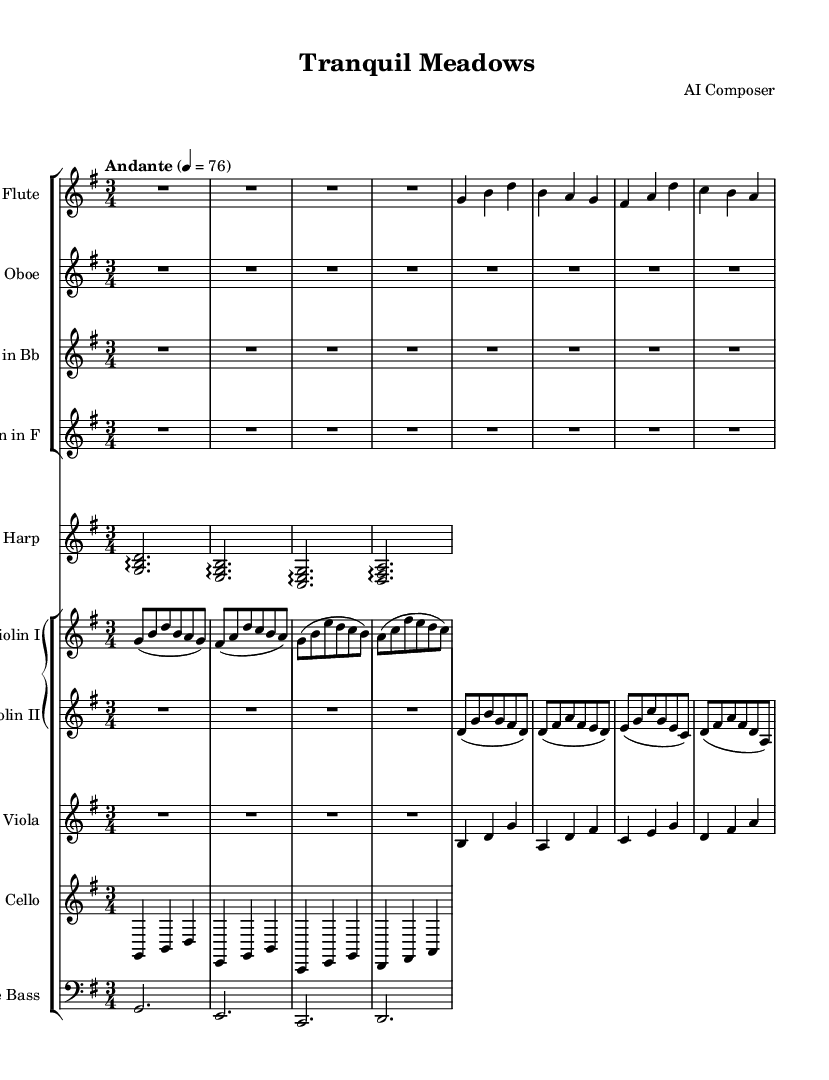What is the key signature of this music? The key signature is G major, which has one sharp (F#). This is indicated at the beginning of the staff with the sharp symbol.
Answer: G major What is the time signature of this sheet music? The time signature is 3/4, which means there are three beats in each measure, and the quarter note gets one beat. This is noticed at the beginning of the piece next to the key signature.
Answer: 3/4 What is the tempo marking for this piece? The tempo marking is "Andante," which indicates a moderate walking pace, specifically with a metronome marking of 76 beats per minute. This is shown above the staff at the beginning of the music.
Answer: Andante How many measures are present in the flute part? The flute part contains four measures, as counted from the beginning to the end of the part. Each measure is separated by a vertical line, which indicates the end of each measure.
Answer: 4 Which instruments are listed in the score? The score includes flute, oboe, clarinet in Bb, horn in F, harp, violin I, violin II, viola, cello, and double bass. Each instrument is labeled above its respective staff in the score.
Answer: Flute, oboe, clarinet in Bb, horn in F, harp, violin I, violin II, viola, cello, double bass What is the rhythmic pattern in the violin I part? The rhythmic pattern in the violin I part primarily consists of eighth notes and quarter notes. Each measure comprises a different combination of these note values, which contribute to the overall serene feel of the piece.
Answer: Eighth notes and quarter notes 